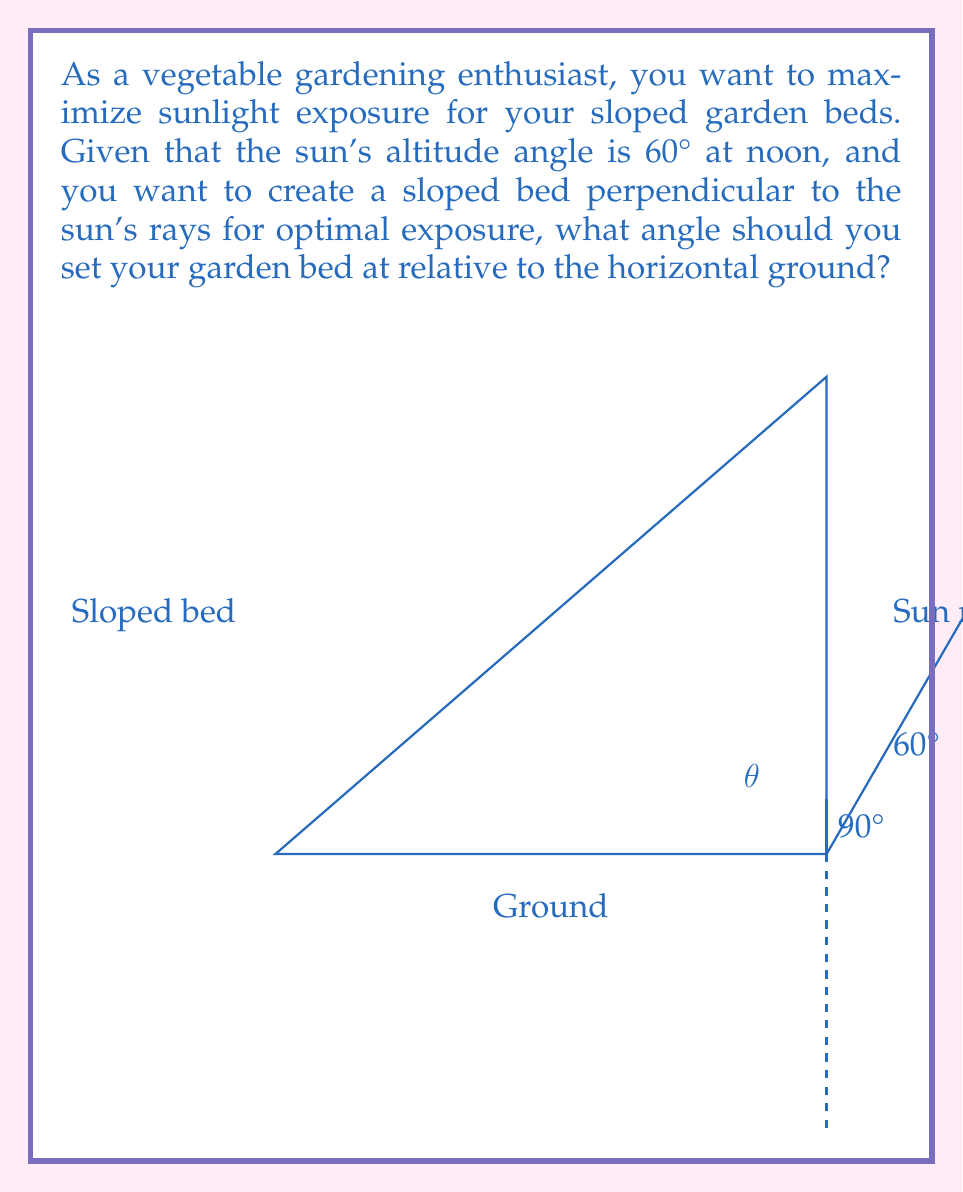Give your solution to this math problem. Let's approach this step-by-step:

1) The goal is to set the garden bed perpendicular to the sun's rays for maximum exposure.

2) We know that perpendicular lines form a 90° angle. So, if we can find the angle between the sun's rays and the horizontal ground, we can subtract that from 90° to get the angle of the sloped bed.

3) The sun's altitude angle is given as 60°. This is the angle between the sun's rays and the horizontal ground.

4) Let $\theta$ be the angle we're looking for (the angle of the sloped bed relative to the ground).

5) We can set up the equation:

   $$\theta + 60° = 90°$$

6) Solving for $\theta$:

   $$\theta = 90° - 60° = 30°$$

Therefore, the garden bed should be set at a 30° angle relative to the horizontal ground to be perpendicular to the sun's rays at noon.
Answer: 30° 